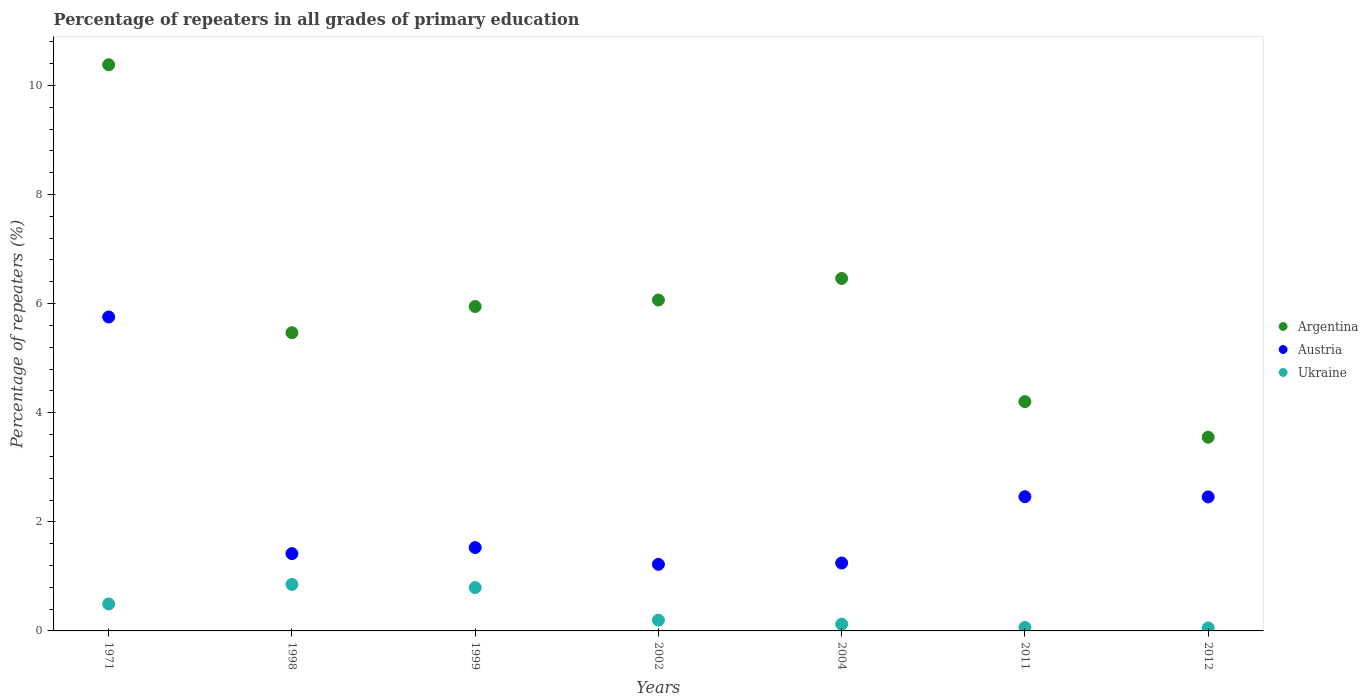How many different coloured dotlines are there?
Your answer should be compact. 3. What is the percentage of repeaters in Ukraine in 1998?
Your answer should be very brief. 0.85. Across all years, what is the maximum percentage of repeaters in Austria?
Provide a short and direct response. 5.75. Across all years, what is the minimum percentage of repeaters in Austria?
Ensure brevity in your answer.  1.22. What is the total percentage of repeaters in Argentina in the graph?
Offer a very short reply. 42.07. What is the difference between the percentage of repeaters in Austria in 1999 and that in 2004?
Ensure brevity in your answer.  0.28. What is the difference between the percentage of repeaters in Ukraine in 2004 and the percentage of repeaters in Argentina in 2012?
Keep it short and to the point. -3.43. What is the average percentage of repeaters in Argentina per year?
Provide a short and direct response. 6.01. In the year 2011, what is the difference between the percentage of repeaters in Argentina and percentage of repeaters in Ukraine?
Give a very brief answer. 4.14. What is the ratio of the percentage of repeaters in Ukraine in 1999 to that in 2004?
Provide a succinct answer. 6.4. Is the percentage of repeaters in Austria in 1999 less than that in 2002?
Make the answer very short. No. What is the difference between the highest and the second highest percentage of repeaters in Argentina?
Offer a terse response. 3.92. What is the difference between the highest and the lowest percentage of repeaters in Austria?
Ensure brevity in your answer.  4.53. In how many years, is the percentage of repeaters in Ukraine greater than the average percentage of repeaters in Ukraine taken over all years?
Provide a succinct answer. 3. Is it the case that in every year, the sum of the percentage of repeaters in Argentina and percentage of repeaters in Austria  is greater than the percentage of repeaters in Ukraine?
Give a very brief answer. Yes. Does the percentage of repeaters in Ukraine monotonically increase over the years?
Offer a very short reply. No. Is the percentage of repeaters in Argentina strictly greater than the percentage of repeaters in Ukraine over the years?
Give a very brief answer. Yes. Is the percentage of repeaters in Austria strictly less than the percentage of repeaters in Ukraine over the years?
Provide a succinct answer. No. How many dotlines are there?
Offer a terse response. 3. What is the difference between two consecutive major ticks on the Y-axis?
Provide a succinct answer. 2. How many legend labels are there?
Provide a succinct answer. 3. What is the title of the graph?
Your response must be concise. Percentage of repeaters in all grades of primary education. Does "Venezuela" appear as one of the legend labels in the graph?
Your response must be concise. No. What is the label or title of the X-axis?
Your answer should be compact. Years. What is the label or title of the Y-axis?
Offer a very short reply. Percentage of repeaters (%). What is the Percentage of repeaters (%) in Argentina in 1971?
Your answer should be very brief. 10.38. What is the Percentage of repeaters (%) of Austria in 1971?
Provide a succinct answer. 5.75. What is the Percentage of repeaters (%) in Ukraine in 1971?
Your answer should be compact. 0.49. What is the Percentage of repeaters (%) in Argentina in 1998?
Keep it short and to the point. 5.47. What is the Percentage of repeaters (%) in Austria in 1998?
Offer a terse response. 1.42. What is the Percentage of repeaters (%) of Ukraine in 1998?
Your answer should be very brief. 0.85. What is the Percentage of repeaters (%) in Argentina in 1999?
Keep it short and to the point. 5.95. What is the Percentage of repeaters (%) in Austria in 1999?
Your answer should be very brief. 1.53. What is the Percentage of repeaters (%) of Ukraine in 1999?
Provide a succinct answer. 0.79. What is the Percentage of repeaters (%) in Argentina in 2002?
Your answer should be very brief. 6.07. What is the Percentage of repeaters (%) of Austria in 2002?
Offer a terse response. 1.22. What is the Percentage of repeaters (%) of Ukraine in 2002?
Ensure brevity in your answer.  0.2. What is the Percentage of repeaters (%) in Argentina in 2004?
Offer a terse response. 6.46. What is the Percentage of repeaters (%) in Austria in 2004?
Give a very brief answer. 1.24. What is the Percentage of repeaters (%) of Ukraine in 2004?
Keep it short and to the point. 0.12. What is the Percentage of repeaters (%) of Argentina in 2011?
Offer a very short reply. 4.2. What is the Percentage of repeaters (%) in Austria in 2011?
Offer a terse response. 2.46. What is the Percentage of repeaters (%) of Ukraine in 2011?
Ensure brevity in your answer.  0.06. What is the Percentage of repeaters (%) in Argentina in 2012?
Your answer should be compact. 3.55. What is the Percentage of repeaters (%) of Austria in 2012?
Make the answer very short. 2.46. What is the Percentage of repeaters (%) in Ukraine in 2012?
Ensure brevity in your answer.  0.06. Across all years, what is the maximum Percentage of repeaters (%) of Argentina?
Give a very brief answer. 10.38. Across all years, what is the maximum Percentage of repeaters (%) in Austria?
Keep it short and to the point. 5.75. Across all years, what is the maximum Percentage of repeaters (%) in Ukraine?
Make the answer very short. 0.85. Across all years, what is the minimum Percentage of repeaters (%) of Argentina?
Your response must be concise. 3.55. Across all years, what is the minimum Percentage of repeaters (%) in Austria?
Offer a terse response. 1.22. Across all years, what is the minimum Percentage of repeaters (%) of Ukraine?
Offer a terse response. 0.06. What is the total Percentage of repeaters (%) in Argentina in the graph?
Provide a short and direct response. 42.08. What is the total Percentage of repeaters (%) of Austria in the graph?
Give a very brief answer. 16.08. What is the total Percentage of repeaters (%) of Ukraine in the graph?
Your response must be concise. 2.58. What is the difference between the Percentage of repeaters (%) of Argentina in 1971 and that in 1998?
Your answer should be very brief. 4.91. What is the difference between the Percentage of repeaters (%) of Austria in 1971 and that in 1998?
Give a very brief answer. 4.34. What is the difference between the Percentage of repeaters (%) in Ukraine in 1971 and that in 1998?
Make the answer very short. -0.36. What is the difference between the Percentage of repeaters (%) in Argentina in 1971 and that in 1999?
Make the answer very short. 4.43. What is the difference between the Percentage of repeaters (%) in Austria in 1971 and that in 1999?
Keep it short and to the point. 4.23. What is the difference between the Percentage of repeaters (%) in Ukraine in 1971 and that in 1999?
Provide a short and direct response. -0.3. What is the difference between the Percentage of repeaters (%) in Argentina in 1971 and that in 2002?
Provide a succinct answer. 4.31. What is the difference between the Percentage of repeaters (%) in Austria in 1971 and that in 2002?
Keep it short and to the point. 4.53. What is the difference between the Percentage of repeaters (%) in Ukraine in 1971 and that in 2002?
Offer a terse response. 0.3. What is the difference between the Percentage of repeaters (%) in Argentina in 1971 and that in 2004?
Your answer should be very brief. 3.92. What is the difference between the Percentage of repeaters (%) of Austria in 1971 and that in 2004?
Offer a terse response. 4.51. What is the difference between the Percentage of repeaters (%) of Ukraine in 1971 and that in 2004?
Your answer should be very brief. 0.37. What is the difference between the Percentage of repeaters (%) in Argentina in 1971 and that in 2011?
Give a very brief answer. 6.18. What is the difference between the Percentage of repeaters (%) in Austria in 1971 and that in 2011?
Your response must be concise. 3.29. What is the difference between the Percentage of repeaters (%) in Ukraine in 1971 and that in 2011?
Your answer should be very brief. 0.43. What is the difference between the Percentage of repeaters (%) of Argentina in 1971 and that in 2012?
Ensure brevity in your answer.  6.83. What is the difference between the Percentage of repeaters (%) in Austria in 1971 and that in 2012?
Provide a short and direct response. 3.3. What is the difference between the Percentage of repeaters (%) in Ukraine in 1971 and that in 2012?
Your answer should be compact. 0.44. What is the difference between the Percentage of repeaters (%) of Argentina in 1998 and that in 1999?
Give a very brief answer. -0.48. What is the difference between the Percentage of repeaters (%) in Austria in 1998 and that in 1999?
Provide a succinct answer. -0.11. What is the difference between the Percentage of repeaters (%) in Ukraine in 1998 and that in 1999?
Give a very brief answer. 0.06. What is the difference between the Percentage of repeaters (%) of Argentina in 1998 and that in 2002?
Your answer should be compact. -0.6. What is the difference between the Percentage of repeaters (%) of Austria in 1998 and that in 2002?
Provide a succinct answer. 0.2. What is the difference between the Percentage of repeaters (%) of Ukraine in 1998 and that in 2002?
Offer a very short reply. 0.66. What is the difference between the Percentage of repeaters (%) of Argentina in 1998 and that in 2004?
Keep it short and to the point. -0.99. What is the difference between the Percentage of repeaters (%) of Austria in 1998 and that in 2004?
Ensure brevity in your answer.  0.17. What is the difference between the Percentage of repeaters (%) of Ukraine in 1998 and that in 2004?
Offer a terse response. 0.73. What is the difference between the Percentage of repeaters (%) in Argentina in 1998 and that in 2011?
Your response must be concise. 1.26. What is the difference between the Percentage of repeaters (%) of Austria in 1998 and that in 2011?
Make the answer very short. -1.04. What is the difference between the Percentage of repeaters (%) of Ukraine in 1998 and that in 2011?
Provide a short and direct response. 0.79. What is the difference between the Percentage of repeaters (%) in Argentina in 1998 and that in 2012?
Your response must be concise. 1.92. What is the difference between the Percentage of repeaters (%) in Austria in 1998 and that in 2012?
Offer a terse response. -1.04. What is the difference between the Percentage of repeaters (%) in Ukraine in 1998 and that in 2012?
Your answer should be compact. 0.8. What is the difference between the Percentage of repeaters (%) of Argentina in 1999 and that in 2002?
Your response must be concise. -0.12. What is the difference between the Percentage of repeaters (%) of Austria in 1999 and that in 2002?
Offer a very short reply. 0.31. What is the difference between the Percentage of repeaters (%) in Ukraine in 1999 and that in 2002?
Ensure brevity in your answer.  0.6. What is the difference between the Percentage of repeaters (%) in Argentina in 1999 and that in 2004?
Provide a succinct answer. -0.51. What is the difference between the Percentage of repeaters (%) of Austria in 1999 and that in 2004?
Give a very brief answer. 0.28. What is the difference between the Percentage of repeaters (%) of Ukraine in 1999 and that in 2004?
Give a very brief answer. 0.67. What is the difference between the Percentage of repeaters (%) of Argentina in 1999 and that in 2011?
Give a very brief answer. 1.74. What is the difference between the Percentage of repeaters (%) of Austria in 1999 and that in 2011?
Your answer should be very brief. -0.93. What is the difference between the Percentage of repeaters (%) of Ukraine in 1999 and that in 2011?
Offer a terse response. 0.73. What is the difference between the Percentage of repeaters (%) of Argentina in 1999 and that in 2012?
Your response must be concise. 2.4. What is the difference between the Percentage of repeaters (%) of Austria in 1999 and that in 2012?
Ensure brevity in your answer.  -0.93. What is the difference between the Percentage of repeaters (%) in Ukraine in 1999 and that in 2012?
Your answer should be very brief. 0.74. What is the difference between the Percentage of repeaters (%) of Argentina in 2002 and that in 2004?
Provide a short and direct response. -0.4. What is the difference between the Percentage of repeaters (%) of Austria in 2002 and that in 2004?
Your answer should be compact. -0.02. What is the difference between the Percentage of repeaters (%) of Ukraine in 2002 and that in 2004?
Keep it short and to the point. 0.07. What is the difference between the Percentage of repeaters (%) in Argentina in 2002 and that in 2011?
Keep it short and to the point. 1.86. What is the difference between the Percentage of repeaters (%) of Austria in 2002 and that in 2011?
Provide a succinct answer. -1.24. What is the difference between the Percentage of repeaters (%) in Ukraine in 2002 and that in 2011?
Your answer should be very brief. 0.13. What is the difference between the Percentage of repeaters (%) of Argentina in 2002 and that in 2012?
Offer a terse response. 2.52. What is the difference between the Percentage of repeaters (%) of Austria in 2002 and that in 2012?
Give a very brief answer. -1.24. What is the difference between the Percentage of repeaters (%) of Ukraine in 2002 and that in 2012?
Give a very brief answer. 0.14. What is the difference between the Percentage of repeaters (%) of Argentina in 2004 and that in 2011?
Your response must be concise. 2.26. What is the difference between the Percentage of repeaters (%) of Austria in 2004 and that in 2011?
Make the answer very short. -1.22. What is the difference between the Percentage of repeaters (%) of Ukraine in 2004 and that in 2011?
Your answer should be very brief. 0.06. What is the difference between the Percentage of repeaters (%) in Argentina in 2004 and that in 2012?
Ensure brevity in your answer.  2.91. What is the difference between the Percentage of repeaters (%) in Austria in 2004 and that in 2012?
Provide a succinct answer. -1.21. What is the difference between the Percentage of repeaters (%) in Ukraine in 2004 and that in 2012?
Ensure brevity in your answer.  0.07. What is the difference between the Percentage of repeaters (%) of Argentina in 2011 and that in 2012?
Keep it short and to the point. 0.65. What is the difference between the Percentage of repeaters (%) of Austria in 2011 and that in 2012?
Provide a short and direct response. 0. What is the difference between the Percentage of repeaters (%) of Ukraine in 2011 and that in 2012?
Provide a short and direct response. 0.01. What is the difference between the Percentage of repeaters (%) of Argentina in 1971 and the Percentage of repeaters (%) of Austria in 1998?
Provide a short and direct response. 8.96. What is the difference between the Percentage of repeaters (%) in Argentina in 1971 and the Percentage of repeaters (%) in Ukraine in 1998?
Offer a very short reply. 9.53. What is the difference between the Percentage of repeaters (%) in Austria in 1971 and the Percentage of repeaters (%) in Ukraine in 1998?
Give a very brief answer. 4.9. What is the difference between the Percentage of repeaters (%) in Argentina in 1971 and the Percentage of repeaters (%) in Austria in 1999?
Make the answer very short. 8.85. What is the difference between the Percentage of repeaters (%) in Argentina in 1971 and the Percentage of repeaters (%) in Ukraine in 1999?
Your answer should be very brief. 9.59. What is the difference between the Percentage of repeaters (%) of Austria in 1971 and the Percentage of repeaters (%) of Ukraine in 1999?
Your response must be concise. 4.96. What is the difference between the Percentage of repeaters (%) of Argentina in 1971 and the Percentage of repeaters (%) of Austria in 2002?
Your answer should be very brief. 9.16. What is the difference between the Percentage of repeaters (%) in Argentina in 1971 and the Percentage of repeaters (%) in Ukraine in 2002?
Your answer should be very brief. 10.18. What is the difference between the Percentage of repeaters (%) in Austria in 1971 and the Percentage of repeaters (%) in Ukraine in 2002?
Make the answer very short. 5.56. What is the difference between the Percentage of repeaters (%) in Argentina in 1971 and the Percentage of repeaters (%) in Austria in 2004?
Your answer should be compact. 9.13. What is the difference between the Percentage of repeaters (%) of Argentina in 1971 and the Percentage of repeaters (%) of Ukraine in 2004?
Ensure brevity in your answer.  10.26. What is the difference between the Percentage of repeaters (%) of Austria in 1971 and the Percentage of repeaters (%) of Ukraine in 2004?
Your response must be concise. 5.63. What is the difference between the Percentage of repeaters (%) in Argentina in 1971 and the Percentage of repeaters (%) in Austria in 2011?
Ensure brevity in your answer.  7.92. What is the difference between the Percentage of repeaters (%) in Argentina in 1971 and the Percentage of repeaters (%) in Ukraine in 2011?
Offer a very short reply. 10.32. What is the difference between the Percentage of repeaters (%) in Austria in 1971 and the Percentage of repeaters (%) in Ukraine in 2011?
Your response must be concise. 5.69. What is the difference between the Percentage of repeaters (%) in Argentina in 1971 and the Percentage of repeaters (%) in Austria in 2012?
Your answer should be compact. 7.92. What is the difference between the Percentage of repeaters (%) of Argentina in 1971 and the Percentage of repeaters (%) of Ukraine in 2012?
Keep it short and to the point. 10.32. What is the difference between the Percentage of repeaters (%) in Austria in 1971 and the Percentage of repeaters (%) in Ukraine in 2012?
Your response must be concise. 5.7. What is the difference between the Percentage of repeaters (%) in Argentina in 1998 and the Percentage of repeaters (%) in Austria in 1999?
Offer a terse response. 3.94. What is the difference between the Percentage of repeaters (%) of Argentina in 1998 and the Percentage of repeaters (%) of Ukraine in 1999?
Your answer should be compact. 4.67. What is the difference between the Percentage of repeaters (%) of Austria in 1998 and the Percentage of repeaters (%) of Ukraine in 1999?
Offer a terse response. 0.62. What is the difference between the Percentage of repeaters (%) of Argentina in 1998 and the Percentage of repeaters (%) of Austria in 2002?
Ensure brevity in your answer.  4.25. What is the difference between the Percentage of repeaters (%) of Argentina in 1998 and the Percentage of repeaters (%) of Ukraine in 2002?
Make the answer very short. 5.27. What is the difference between the Percentage of repeaters (%) of Austria in 1998 and the Percentage of repeaters (%) of Ukraine in 2002?
Provide a succinct answer. 1.22. What is the difference between the Percentage of repeaters (%) of Argentina in 1998 and the Percentage of repeaters (%) of Austria in 2004?
Your answer should be compact. 4.22. What is the difference between the Percentage of repeaters (%) in Argentina in 1998 and the Percentage of repeaters (%) in Ukraine in 2004?
Ensure brevity in your answer.  5.34. What is the difference between the Percentage of repeaters (%) in Austria in 1998 and the Percentage of repeaters (%) in Ukraine in 2004?
Make the answer very short. 1.29. What is the difference between the Percentage of repeaters (%) of Argentina in 1998 and the Percentage of repeaters (%) of Austria in 2011?
Provide a short and direct response. 3.01. What is the difference between the Percentage of repeaters (%) of Argentina in 1998 and the Percentage of repeaters (%) of Ukraine in 2011?
Give a very brief answer. 5.4. What is the difference between the Percentage of repeaters (%) in Austria in 1998 and the Percentage of repeaters (%) in Ukraine in 2011?
Your answer should be very brief. 1.35. What is the difference between the Percentage of repeaters (%) in Argentina in 1998 and the Percentage of repeaters (%) in Austria in 2012?
Your answer should be compact. 3.01. What is the difference between the Percentage of repeaters (%) in Argentina in 1998 and the Percentage of repeaters (%) in Ukraine in 2012?
Offer a very short reply. 5.41. What is the difference between the Percentage of repeaters (%) of Austria in 1998 and the Percentage of repeaters (%) of Ukraine in 2012?
Offer a very short reply. 1.36. What is the difference between the Percentage of repeaters (%) in Argentina in 1999 and the Percentage of repeaters (%) in Austria in 2002?
Your answer should be compact. 4.73. What is the difference between the Percentage of repeaters (%) of Argentina in 1999 and the Percentage of repeaters (%) of Ukraine in 2002?
Your answer should be compact. 5.75. What is the difference between the Percentage of repeaters (%) in Austria in 1999 and the Percentage of repeaters (%) in Ukraine in 2002?
Ensure brevity in your answer.  1.33. What is the difference between the Percentage of repeaters (%) in Argentina in 1999 and the Percentage of repeaters (%) in Austria in 2004?
Your response must be concise. 4.7. What is the difference between the Percentage of repeaters (%) of Argentina in 1999 and the Percentage of repeaters (%) of Ukraine in 2004?
Give a very brief answer. 5.82. What is the difference between the Percentage of repeaters (%) of Austria in 1999 and the Percentage of repeaters (%) of Ukraine in 2004?
Your answer should be very brief. 1.4. What is the difference between the Percentage of repeaters (%) of Argentina in 1999 and the Percentage of repeaters (%) of Austria in 2011?
Keep it short and to the point. 3.49. What is the difference between the Percentage of repeaters (%) in Argentina in 1999 and the Percentage of repeaters (%) in Ukraine in 2011?
Ensure brevity in your answer.  5.88. What is the difference between the Percentage of repeaters (%) in Austria in 1999 and the Percentage of repeaters (%) in Ukraine in 2011?
Provide a succinct answer. 1.46. What is the difference between the Percentage of repeaters (%) in Argentina in 1999 and the Percentage of repeaters (%) in Austria in 2012?
Make the answer very short. 3.49. What is the difference between the Percentage of repeaters (%) of Argentina in 1999 and the Percentage of repeaters (%) of Ukraine in 2012?
Provide a succinct answer. 5.89. What is the difference between the Percentage of repeaters (%) in Austria in 1999 and the Percentage of repeaters (%) in Ukraine in 2012?
Offer a very short reply. 1.47. What is the difference between the Percentage of repeaters (%) of Argentina in 2002 and the Percentage of repeaters (%) of Austria in 2004?
Provide a succinct answer. 4.82. What is the difference between the Percentage of repeaters (%) in Argentina in 2002 and the Percentage of repeaters (%) in Ukraine in 2004?
Ensure brevity in your answer.  5.94. What is the difference between the Percentage of repeaters (%) in Austria in 2002 and the Percentage of repeaters (%) in Ukraine in 2004?
Your response must be concise. 1.1. What is the difference between the Percentage of repeaters (%) of Argentina in 2002 and the Percentage of repeaters (%) of Austria in 2011?
Offer a very short reply. 3.61. What is the difference between the Percentage of repeaters (%) of Argentina in 2002 and the Percentage of repeaters (%) of Ukraine in 2011?
Provide a short and direct response. 6. What is the difference between the Percentage of repeaters (%) of Austria in 2002 and the Percentage of repeaters (%) of Ukraine in 2011?
Offer a terse response. 1.16. What is the difference between the Percentage of repeaters (%) in Argentina in 2002 and the Percentage of repeaters (%) in Austria in 2012?
Offer a terse response. 3.61. What is the difference between the Percentage of repeaters (%) of Argentina in 2002 and the Percentage of repeaters (%) of Ukraine in 2012?
Offer a terse response. 6.01. What is the difference between the Percentage of repeaters (%) of Austria in 2002 and the Percentage of repeaters (%) of Ukraine in 2012?
Your answer should be compact. 1.16. What is the difference between the Percentage of repeaters (%) in Argentina in 2004 and the Percentage of repeaters (%) in Austria in 2011?
Ensure brevity in your answer.  4. What is the difference between the Percentage of repeaters (%) of Argentina in 2004 and the Percentage of repeaters (%) of Ukraine in 2011?
Your response must be concise. 6.4. What is the difference between the Percentage of repeaters (%) of Austria in 2004 and the Percentage of repeaters (%) of Ukraine in 2011?
Provide a succinct answer. 1.18. What is the difference between the Percentage of repeaters (%) of Argentina in 2004 and the Percentage of repeaters (%) of Austria in 2012?
Offer a very short reply. 4. What is the difference between the Percentage of repeaters (%) of Argentina in 2004 and the Percentage of repeaters (%) of Ukraine in 2012?
Offer a terse response. 6.41. What is the difference between the Percentage of repeaters (%) in Austria in 2004 and the Percentage of repeaters (%) in Ukraine in 2012?
Provide a succinct answer. 1.19. What is the difference between the Percentage of repeaters (%) of Argentina in 2011 and the Percentage of repeaters (%) of Austria in 2012?
Your response must be concise. 1.75. What is the difference between the Percentage of repeaters (%) in Argentina in 2011 and the Percentage of repeaters (%) in Ukraine in 2012?
Offer a terse response. 4.15. What is the difference between the Percentage of repeaters (%) of Austria in 2011 and the Percentage of repeaters (%) of Ukraine in 2012?
Keep it short and to the point. 2.4. What is the average Percentage of repeaters (%) of Argentina per year?
Your answer should be very brief. 6.01. What is the average Percentage of repeaters (%) in Austria per year?
Your response must be concise. 2.3. What is the average Percentage of repeaters (%) in Ukraine per year?
Give a very brief answer. 0.37. In the year 1971, what is the difference between the Percentage of repeaters (%) of Argentina and Percentage of repeaters (%) of Austria?
Keep it short and to the point. 4.62. In the year 1971, what is the difference between the Percentage of repeaters (%) in Argentina and Percentage of repeaters (%) in Ukraine?
Ensure brevity in your answer.  9.88. In the year 1971, what is the difference between the Percentage of repeaters (%) in Austria and Percentage of repeaters (%) in Ukraine?
Your response must be concise. 5.26. In the year 1998, what is the difference between the Percentage of repeaters (%) in Argentina and Percentage of repeaters (%) in Austria?
Your response must be concise. 4.05. In the year 1998, what is the difference between the Percentage of repeaters (%) of Argentina and Percentage of repeaters (%) of Ukraine?
Provide a succinct answer. 4.61. In the year 1998, what is the difference between the Percentage of repeaters (%) of Austria and Percentage of repeaters (%) of Ukraine?
Offer a terse response. 0.56. In the year 1999, what is the difference between the Percentage of repeaters (%) of Argentina and Percentage of repeaters (%) of Austria?
Provide a succinct answer. 4.42. In the year 1999, what is the difference between the Percentage of repeaters (%) in Argentina and Percentage of repeaters (%) in Ukraine?
Offer a very short reply. 5.15. In the year 1999, what is the difference between the Percentage of repeaters (%) in Austria and Percentage of repeaters (%) in Ukraine?
Make the answer very short. 0.73. In the year 2002, what is the difference between the Percentage of repeaters (%) in Argentina and Percentage of repeaters (%) in Austria?
Offer a terse response. 4.85. In the year 2002, what is the difference between the Percentage of repeaters (%) of Argentina and Percentage of repeaters (%) of Ukraine?
Keep it short and to the point. 5.87. In the year 2002, what is the difference between the Percentage of repeaters (%) in Austria and Percentage of repeaters (%) in Ukraine?
Your response must be concise. 1.02. In the year 2004, what is the difference between the Percentage of repeaters (%) in Argentina and Percentage of repeaters (%) in Austria?
Offer a terse response. 5.22. In the year 2004, what is the difference between the Percentage of repeaters (%) in Argentina and Percentage of repeaters (%) in Ukraine?
Offer a terse response. 6.34. In the year 2004, what is the difference between the Percentage of repeaters (%) in Austria and Percentage of repeaters (%) in Ukraine?
Your response must be concise. 1.12. In the year 2011, what is the difference between the Percentage of repeaters (%) of Argentina and Percentage of repeaters (%) of Austria?
Keep it short and to the point. 1.74. In the year 2011, what is the difference between the Percentage of repeaters (%) in Argentina and Percentage of repeaters (%) in Ukraine?
Give a very brief answer. 4.14. In the year 2011, what is the difference between the Percentage of repeaters (%) in Austria and Percentage of repeaters (%) in Ukraine?
Ensure brevity in your answer.  2.4. In the year 2012, what is the difference between the Percentage of repeaters (%) of Argentina and Percentage of repeaters (%) of Austria?
Offer a very short reply. 1.09. In the year 2012, what is the difference between the Percentage of repeaters (%) of Argentina and Percentage of repeaters (%) of Ukraine?
Offer a very short reply. 3.49. In the year 2012, what is the difference between the Percentage of repeaters (%) of Austria and Percentage of repeaters (%) of Ukraine?
Provide a succinct answer. 2.4. What is the ratio of the Percentage of repeaters (%) of Argentina in 1971 to that in 1998?
Your answer should be very brief. 1.9. What is the ratio of the Percentage of repeaters (%) of Austria in 1971 to that in 1998?
Offer a very short reply. 4.06. What is the ratio of the Percentage of repeaters (%) in Ukraine in 1971 to that in 1998?
Make the answer very short. 0.58. What is the ratio of the Percentage of repeaters (%) of Argentina in 1971 to that in 1999?
Offer a terse response. 1.75. What is the ratio of the Percentage of repeaters (%) of Austria in 1971 to that in 1999?
Make the answer very short. 3.77. What is the ratio of the Percentage of repeaters (%) of Ukraine in 1971 to that in 1999?
Offer a very short reply. 0.62. What is the ratio of the Percentage of repeaters (%) of Argentina in 1971 to that in 2002?
Your answer should be very brief. 1.71. What is the ratio of the Percentage of repeaters (%) of Austria in 1971 to that in 2002?
Your response must be concise. 4.72. What is the ratio of the Percentage of repeaters (%) of Ukraine in 1971 to that in 2002?
Ensure brevity in your answer.  2.51. What is the ratio of the Percentage of repeaters (%) of Argentina in 1971 to that in 2004?
Offer a terse response. 1.61. What is the ratio of the Percentage of repeaters (%) of Austria in 1971 to that in 2004?
Your answer should be compact. 4.62. What is the ratio of the Percentage of repeaters (%) of Ukraine in 1971 to that in 2004?
Ensure brevity in your answer.  3.99. What is the ratio of the Percentage of repeaters (%) of Argentina in 1971 to that in 2011?
Provide a succinct answer. 2.47. What is the ratio of the Percentage of repeaters (%) of Austria in 1971 to that in 2011?
Give a very brief answer. 2.34. What is the ratio of the Percentage of repeaters (%) of Ukraine in 1971 to that in 2011?
Make the answer very short. 7.74. What is the ratio of the Percentage of repeaters (%) in Argentina in 1971 to that in 2012?
Make the answer very short. 2.92. What is the ratio of the Percentage of repeaters (%) in Austria in 1971 to that in 2012?
Provide a succinct answer. 2.34. What is the ratio of the Percentage of repeaters (%) of Ukraine in 1971 to that in 2012?
Provide a succinct answer. 8.86. What is the ratio of the Percentage of repeaters (%) of Argentina in 1998 to that in 1999?
Provide a short and direct response. 0.92. What is the ratio of the Percentage of repeaters (%) in Austria in 1998 to that in 1999?
Give a very brief answer. 0.93. What is the ratio of the Percentage of repeaters (%) in Ukraine in 1998 to that in 1999?
Give a very brief answer. 1.07. What is the ratio of the Percentage of repeaters (%) in Argentina in 1998 to that in 2002?
Your response must be concise. 0.9. What is the ratio of the Percentage of repeaters (%) in Austria in 1998 to that in 2002?
Give a very brief answer. 1.16. What is the ratio of the Percentage of repeaters (%) of Ukraine in 1998 to that in 2002?
Your response must be concise. 4.33. What is the ratio of the Percentage of repeaters (%) of Argentina in 1998 to that in 2004?
Provide a succinct answer. 0.85. What is the ratio of the Percentage of repeaters (%) in Austria in 1998 to that in 2004?
Your answer should be compact. 1.14. What is the ratio of the Percentage of repeaters (%) in Ukraine in 1998 to that in 2004?
Provide a succinct answer. 6.87. What is the ratio of the Percentage of repeaters (%) in Argentina in 1998 to that in 2011?
Provide a succinct answer. 1.3. What is the ratio of the Percentage of repeaters (%) in Austria in 1998 to that in 2011?
Provide a succinct answer. 0.58. What is the ratio of the Percentage of repeaters (%) of Ukraine in 1998 to that in 2011?
Give a very brief answer. 13.33. What is the ratio of the Percentage of repeaters (%) of Argentina in 1998 to that in 2012?
Ensure brevity in your answer.  1.54. What is the ratio of the Percentage of repeaters (%) in Austria in 1998 to that in 2012?
Offer a terse response. 0.58. What is the ratio of the Percentage of repeaters (%) of Ukraine in 1998 to that in 2012?
Offer a very short reply. 15.26. What is the ratio of the Percentage of repeaters (%) of Argentina in 1999 to that in 2002?
Give a very brief answer. 0.98. What is the ratio of the Percentage of repeaters (%) in Austria in 1999 to that in 2002?
Your answer should be very brief. 1.25. What is the ratio of the Percentage of repeaters (%) in Ukraine in 1999 to that in 2002?
Give a very brief answer. 4.04. What is the ratio of the Percentage of repeaters (%) in Argentina in 1999 to that in 2004?
Provide a short and direct response. 0.92. What is the ratio of the Percentage of repeaters (%) of Austria in 1999 to that in 2004?
Make the answer very short. 1.23. What is the ratio of the Percentage of repeaters (%) in Ukraine in 1999 to that in 2004?
Ensure brevity in your answer.  6.4. What is the ratio of the Percentage of repeaters (%) in Argentina in 1999 to that in 2011?
Your answer should be very brief. 1.41. What is the ratio of the Percentage of repeaters (%) of Austria in 1999 to that in 2011?
Provide a succinct answer. 0.62. What is the ratio of the Percentage of repeaters (%) of Ukraine in 1999 to that in 2011?
Offer a terse response. 12.42. What is the ratio of the Percentage of repeaters (%) of Argentina in 1999 to that in 2012?
Your answer should be compact. 1.68. What is the ratio of the Percentage of repeaters (%) in Austria in 1999 to that in 2012?
Offer a very short reply. 0.62. What is the ratio of the Percentage of repeaters (%) of Ukraine in 1999 to that in 2012?
Your answer should be compact. 14.22. What is the ratio of the Percentage of repeaters (%) in Argentina in 2002 to that in 2004?
Offer a terse response. 0.94. What is the ratio of the Percentage of repeaters (%) in Austria in 2002 to that in 2004?
Offer a very short reply. 0.98. What is the ratio of the Percentage of repeaters (%) in Ukraine in 2002 to that in 2004?
Provide a short and direct response. 1.59. What is the ratio of the Percentage of repeaters (%) of Argentina in 2002 to that in 2011?
Your answer should be very brief. 1.44. What is the ratio of the Percentage of repeaters (%) of Austria in 2002 to that in 2011?
Provide a succinct answer. 0.5. What is the ratio of the Percentage of repeaters (%) in Ukraine in 2002 to that in 2011?
Your answer should be very brief. 3.08. What is the ratio of the Percentage of repeaters (%) in Argentina in 2002 to that in 2012?
Offer a very short reply. 1.71. What is the ratio of the Percentage of repeaters (%) of Austria in 2002 to that in 2012?
Offer a terse response. 0.5. What is the ratio of the Percentage of repeaters (%) of Ukraine in 2002 to that in 2012?
Give a very brief answer. 3.52. What is the ratio of the Percentage of repeaters (%) of Argentina in 2004 to that in 2011?
Give a very brief answer. 1.54. What is the ratio of the Percentage of repeaters (%) in Austria in 2004 to that in 2011?
Give a very brief answer. 0.51. What is the ratio of the Percentage of repeaters (%) of Ukraine in 2004 to that in 2011?
Keep it short and to the point. 1.94. What is the ratio of the Percentage of repeaters (%) in Argentina in 2004 to that in 2012?
Your response must be concise. 1.82. What is the ratio of the Percentage of repeaters (%) in Austria in 2004 to that in 2012?
Ensure brevity in your answer.  0.51. What is the ratio of the Percentage of repeaters (%) in Ukraine in 2004 to that in 2012?
Provide a succinct answer. 2.22. What is the ratio of the Percentage of repeaters (%) of Argentina in 2011 to that in 2012?
Provide a succinct answer. 1.18. What is the ratio of the Percentage of repeaters (%) of Ukraine in 2011 to that in 2012?
Ensure brevity in your answer.  1.15. What is the difference between the highest and the second highest Percentage of repeaters (%) in Argentina?
Ensure brevity in your answer.  3.92. What is the difference between the highest and the second highest Percentage of repeaters (%) in Austria?
Provide a short and direct response. 3.29. What is the difference between the highest and the second highest Percentage of repeaters (%) in Ukraine?
Provide a succinct answer. 0.06. What is the difference between the highest and the lowest Percentage of repeaters (%) in Argentina?
Your answer should be very brief. 6.83. What is the difference between the highest and the lowest Percentage of repeaters (%) in Austria?
Keep it short and to the point. 4.53. What is the difference between the highest and the lowest Percentage of repeaters (%) of Ukraine?
Offer a very short reply. 0.8. 